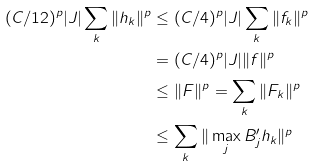<formula> <loc_0><loc_0><loc_500><loc_500>( C / 1 2 ) ^ { p } | J | \sum _ { k } \| h _ { k } \| ^ { p } & \leq ( C / 4 ) ^ { p } | J | \sum _ { k } \| f _ { k } \| ^ { p } \\ & = ( C / 4 ) ^ { p } | J | \| f \| ^ { p } \\ & \leq \| F \| ^ { p } = \sum _ { k } \| F _ { k } \| ^ { p } \\ & \leq \sum _ { k } \| \max _ { j } B _ { j } ^ { \prime } h _ { k } \| ^ { p }</formula> 